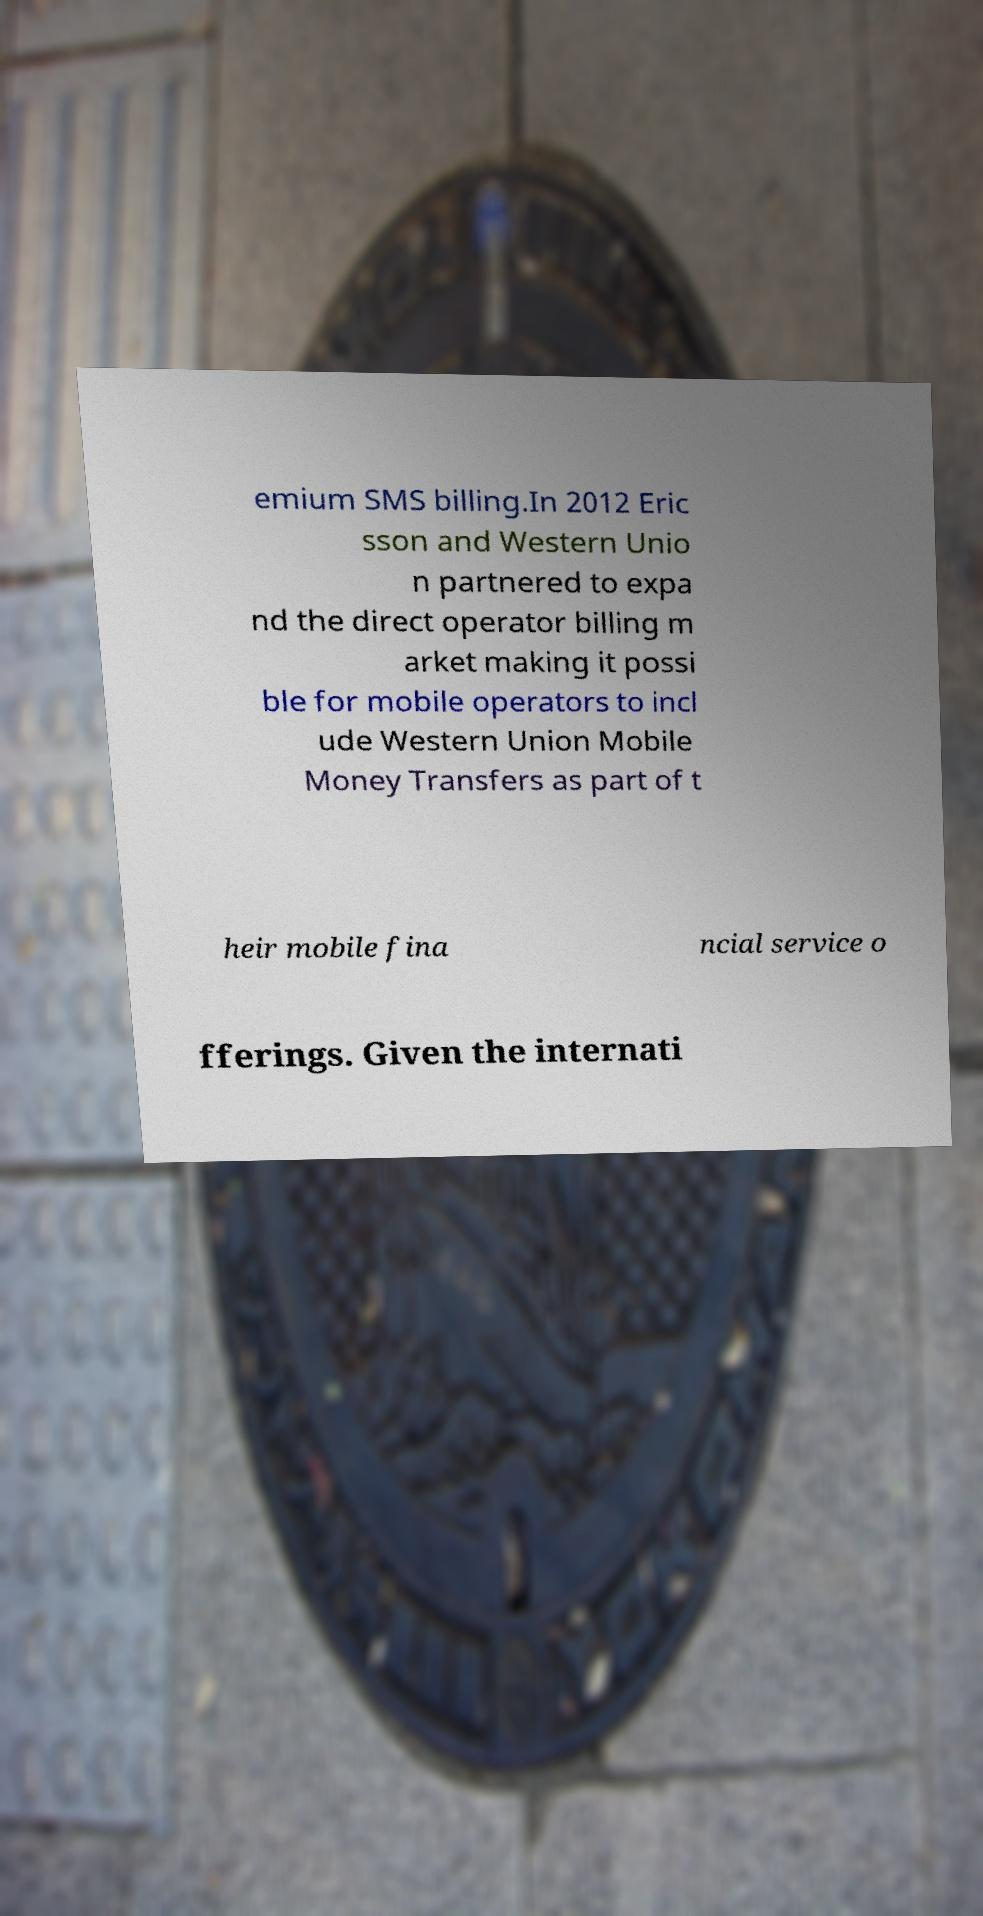Can you accurately transcribe the text from the provided image for me? emium SMS billing.In 2012 Eric sson and Western Unio n partnered to expa nd the direct operator billing m arket making it possi ble for mobile operators to incl ude Western Union Mobile Money Transfers as part of t heir mobile fina ncial service o fferings. Given the internati 